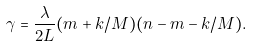<formula> <loc_0><loc_0><loc_500><loc_500>\gamma = \frac { \lambda } { 2 L } ( m + k / M ) ( n - m - k / M ) .</formula> 